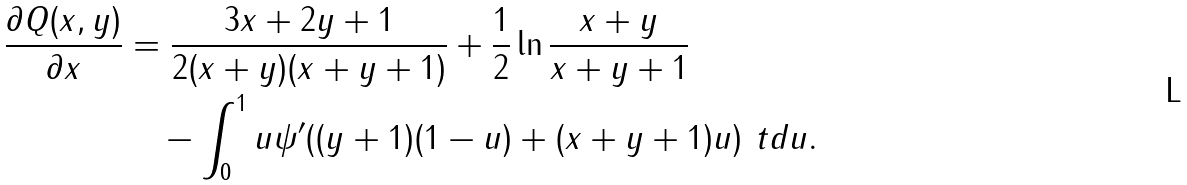<formula> <loc_0><loc_0><loc_500><loc_500>\frac { \partial Q ( x , y ) } { \partial x } & = \frac { 3 x + 2 y + 1 } { 2 ( x + y ) ( x + y + 1 ) } + \frac { 1 } { 2 } \ln \frac { x + y } { x + y + 1 } \\ & \quad - \int _ { 0 } ^ { 1 } u \psi ^ { \prime } ( ( y + 1 ) ( 1 - u ) + ( x + y + 1 ) u ) \ t d u .</formula> 